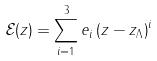Convert formula to latex. <formula><loc_0><loc_0><loc_500><loc_500>\mathcal { E } ( z ) = \sum _ { i = 1 } ^ { 3 } e _ { i } \left ( z - z _ { \Lambda } \right ) ^ { i }</formula> 